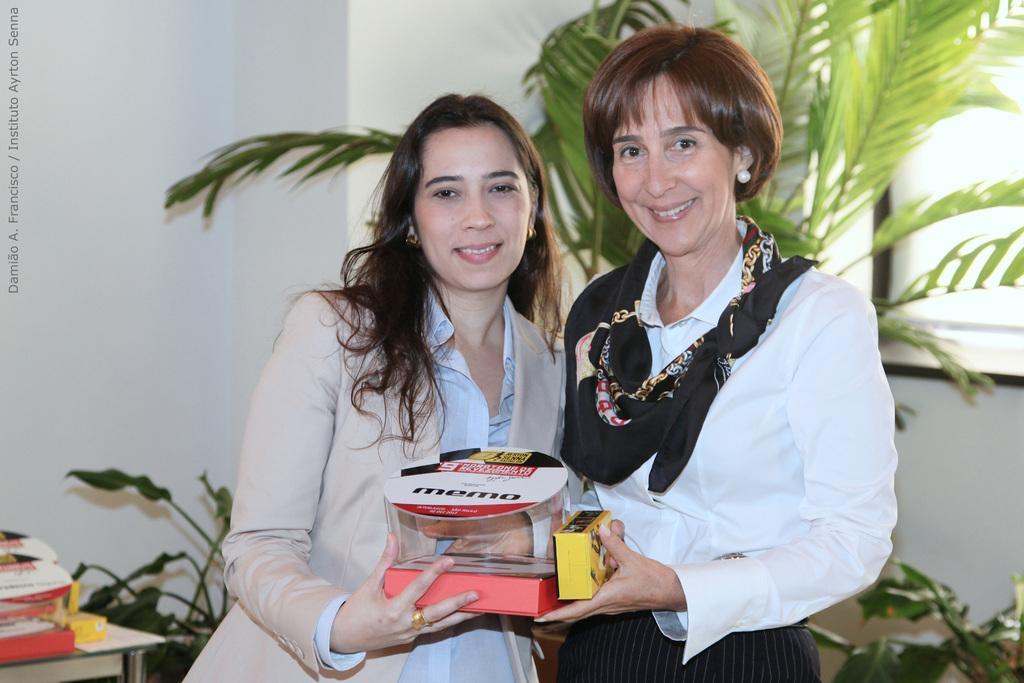Can you describe this image briefly? In this image we can see two persons holding two objects, there we can see a window, tree, few plants, some objects on the table, a wall and a text on the left of the image. 